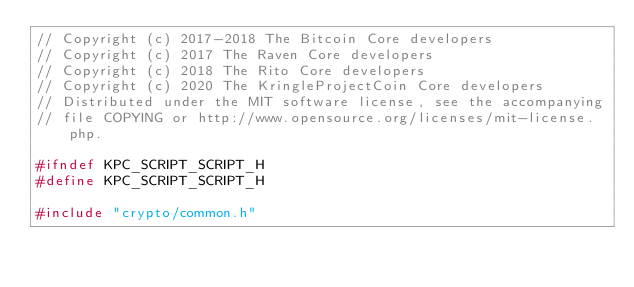<code> <loc_0><loc_0><loc_500><loc_500><_C_>// Copyright (c) 2017-2018 The Bitcoin Core developers
// Copyright (c) 2017 The Raven Core developers
// Copyright (c) 2018 The Rito Core developers
// Copyright (c) 2020 The KringleProjectCoin Core developers
// Distributed under the MIT software license, see the accompanying
// file COPYING or http://www.opensource.org/licenses/mit-license.php.

#ifndef KPC_SCRIPT_SCRIPT_H
#define KPC_SCRIPT_SCRIPT_H

#include "crypto/common.h"</code> 